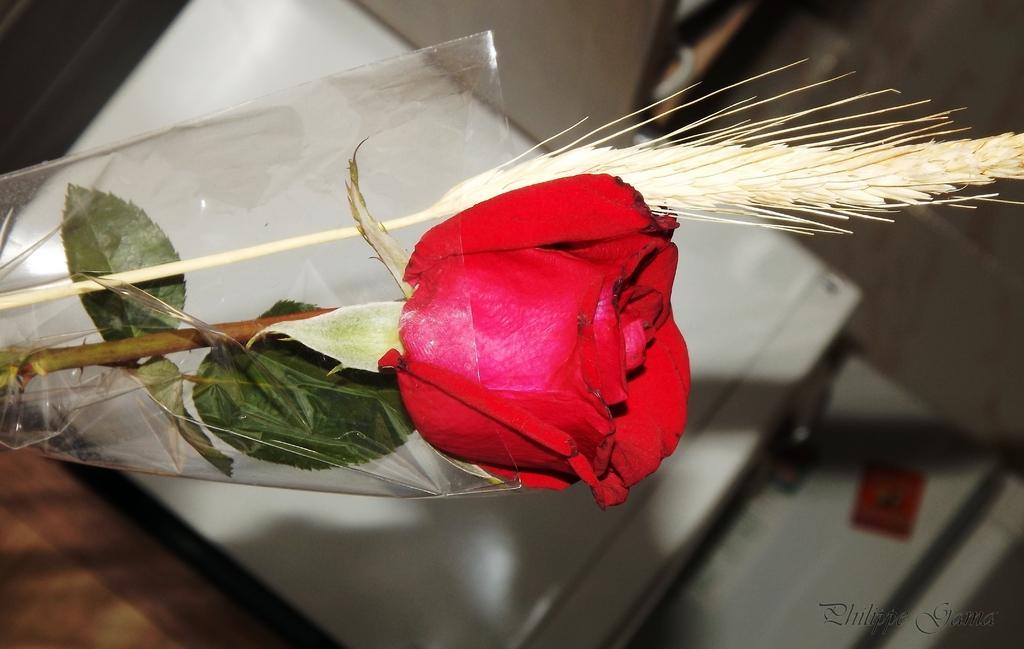How would you summarize this image in a sentence or two? In this picture I can observe red color rose flower. The background is blurred. 